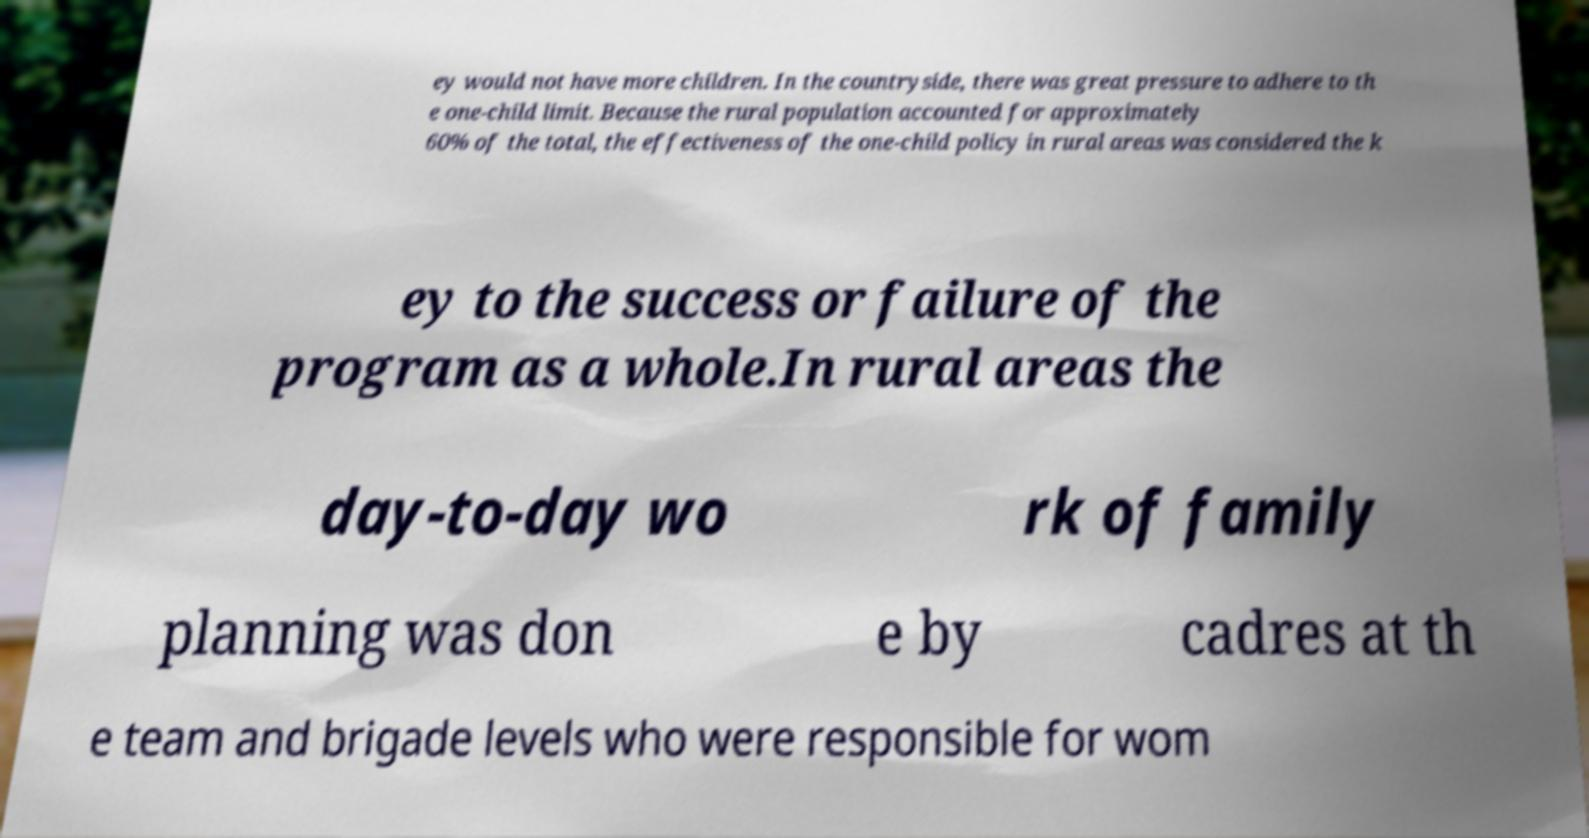Can you read and provide the text displayed in the image?This photo seems to have some interesting text. Can you extract and type it out for me? ey would not have more children. In the countryside, there was great pressure to adhere to th e one-child limit. Because the rural population accounted for approximately 60% of the total, the effectiveness of the one-child policy in rural areas was considered the k ey to the success or failure of the program as a whole.In rural areas the day-to-day wo rk of family planning was don e by cadres at th e team and brigade levels who were responsible for wom 